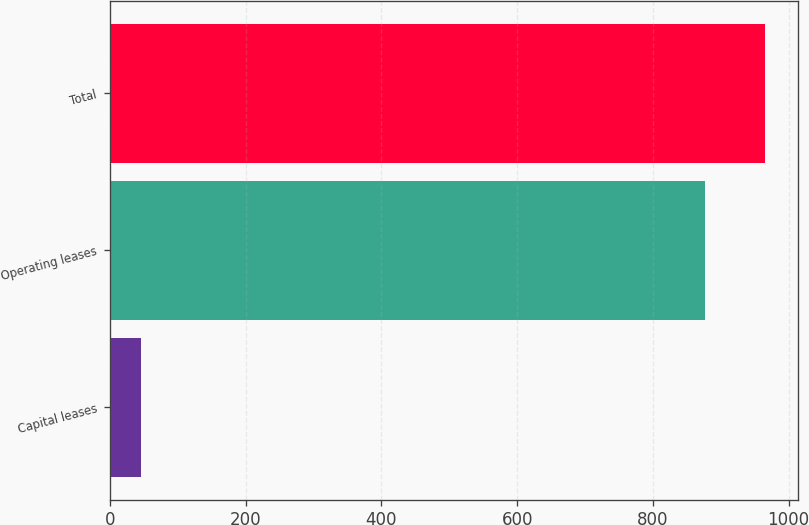Convert chart. <chart><loc_0><loc_0><loc_500><loc_500><bar_chart><fcel>Capital leases<fcel>Operating leases<fcel>Total<nl><fcel>46<fcel>877.3<fcel>965.03<nl></chart> 